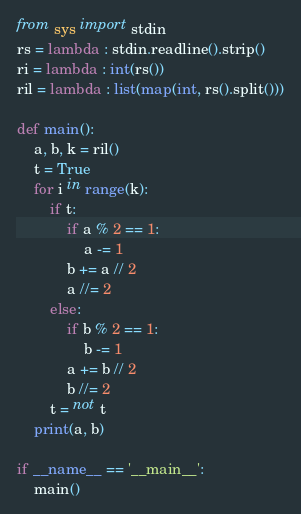Convert code to text. <code><loc_0><loc_0><loc_500><loc_500><_Python_>from sys import stdin
rs = lambda : stdin.readline().strip()
ri = lambda : int(rs())
ril = lambda : list(map(int, rs().split()))

def main():
    a, b, k = ril()
    t = True
    for i in range(k):
        if t:
            if a % 2 == 1:
                a -= 1
            b += a // 2
            a //= 2
        else:
            if b % 2 == 1:
                b -= 1
            a += b // 2
            b //= 2
        t = not t
    print(a, b)

if __name__ == '__main__':
    main()
</code> 